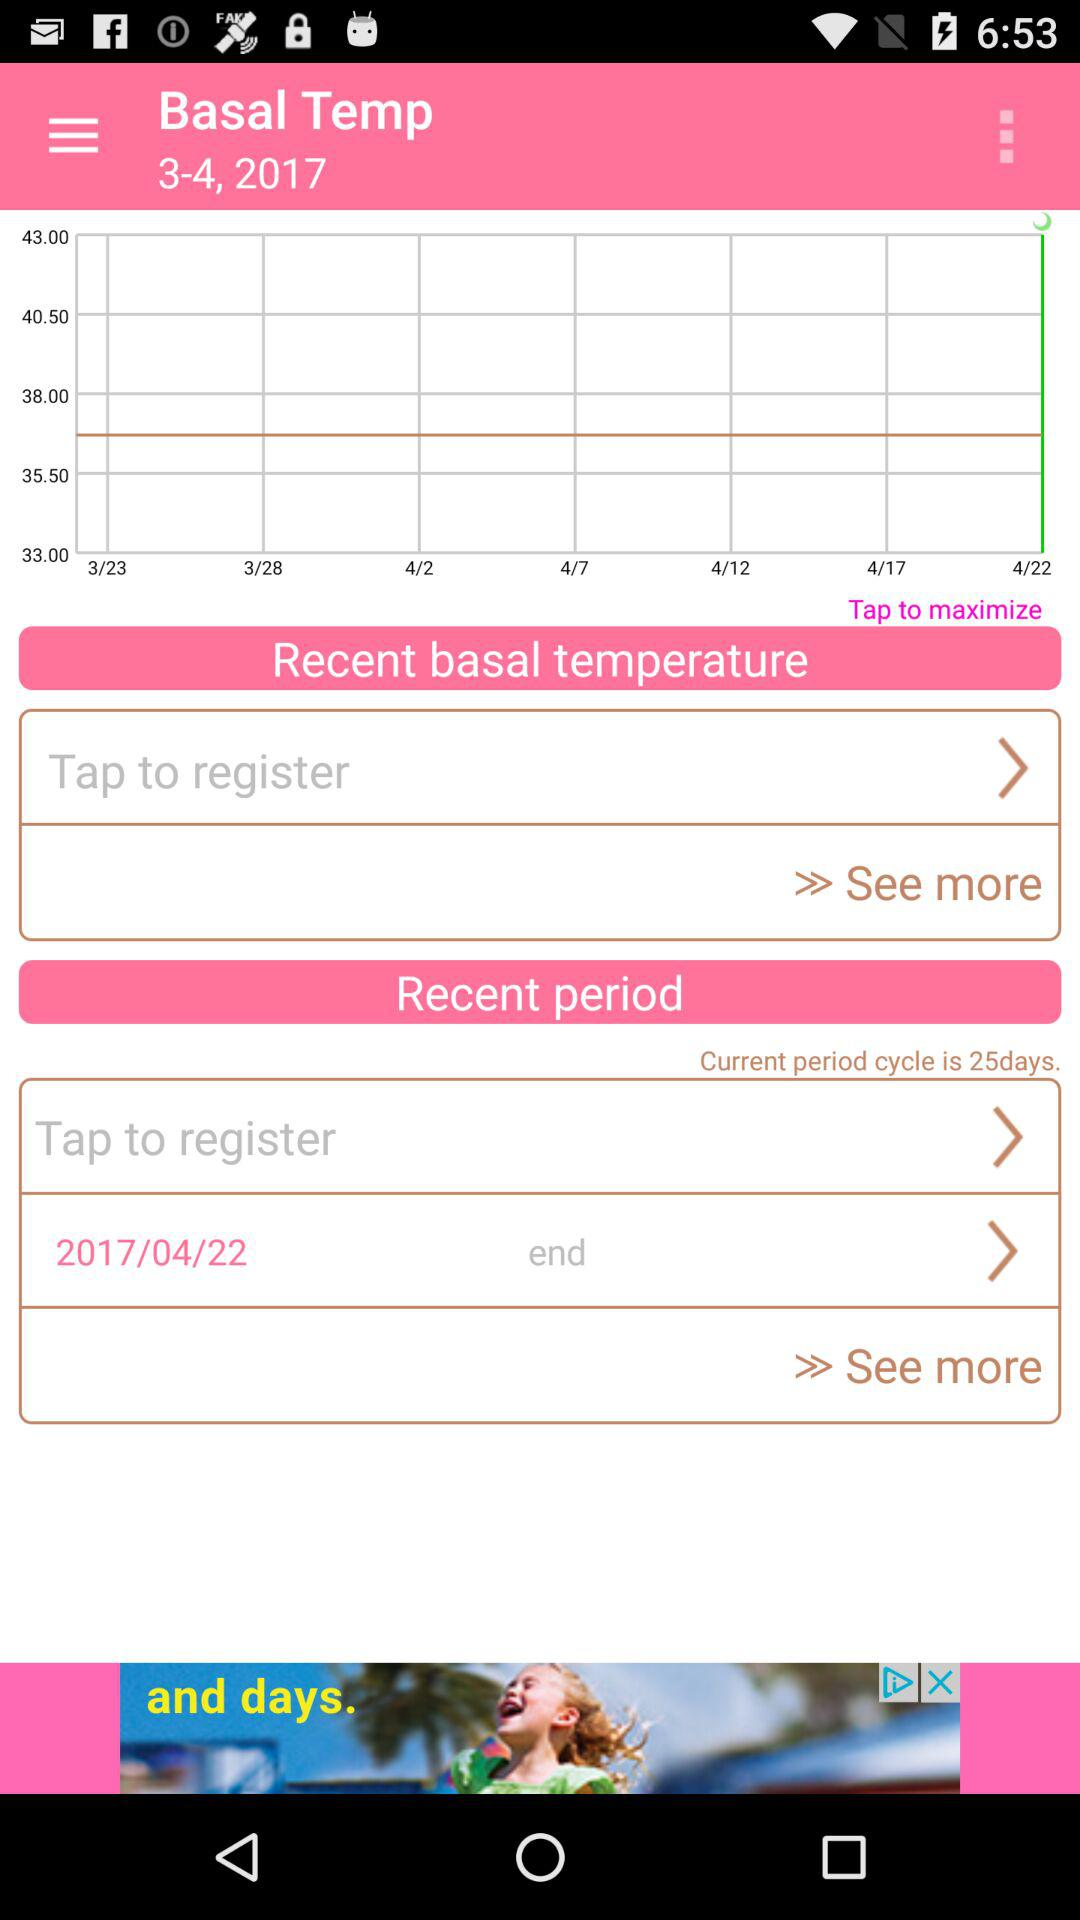What's the start date of the period? The start date of the period is April 22, 2017. 